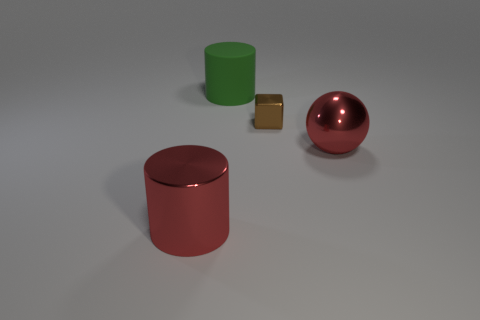Are there any other things that are the same shape as the brown metallic object?
Offer a very short reply. No. There is a large cylinder in front of the cylinder behind the big shiny object on the left side of the green rubber cylinder; what is its color?
Your answer should be compact. Red. Is the number of green things that are right of the ball less than the number of big objects that are behind the brown metallic thing?
Make the answer very short. Yes. Do the tiny object and the matte thing have the same shape?
Your response must be concise. No. How many balls have the same size as the brown metallic block?
Offer a very short reply. 0. Are there fewer red metal things behind the red sphere than red shiny objects?
Make the answer very short. Yes. What is the size of the green thing left of the metal thing that is behind the ball?
Provide a succinct answer. Large. What number of things are green cylinders or brown cubes?
Your answer should be compact. 2. Is there a tiny object of the same color as the ball?
Your answer should be compact. No. Is the number of green matte objects less than the number of large blue rubber balls?
Make the answer very short. No. 